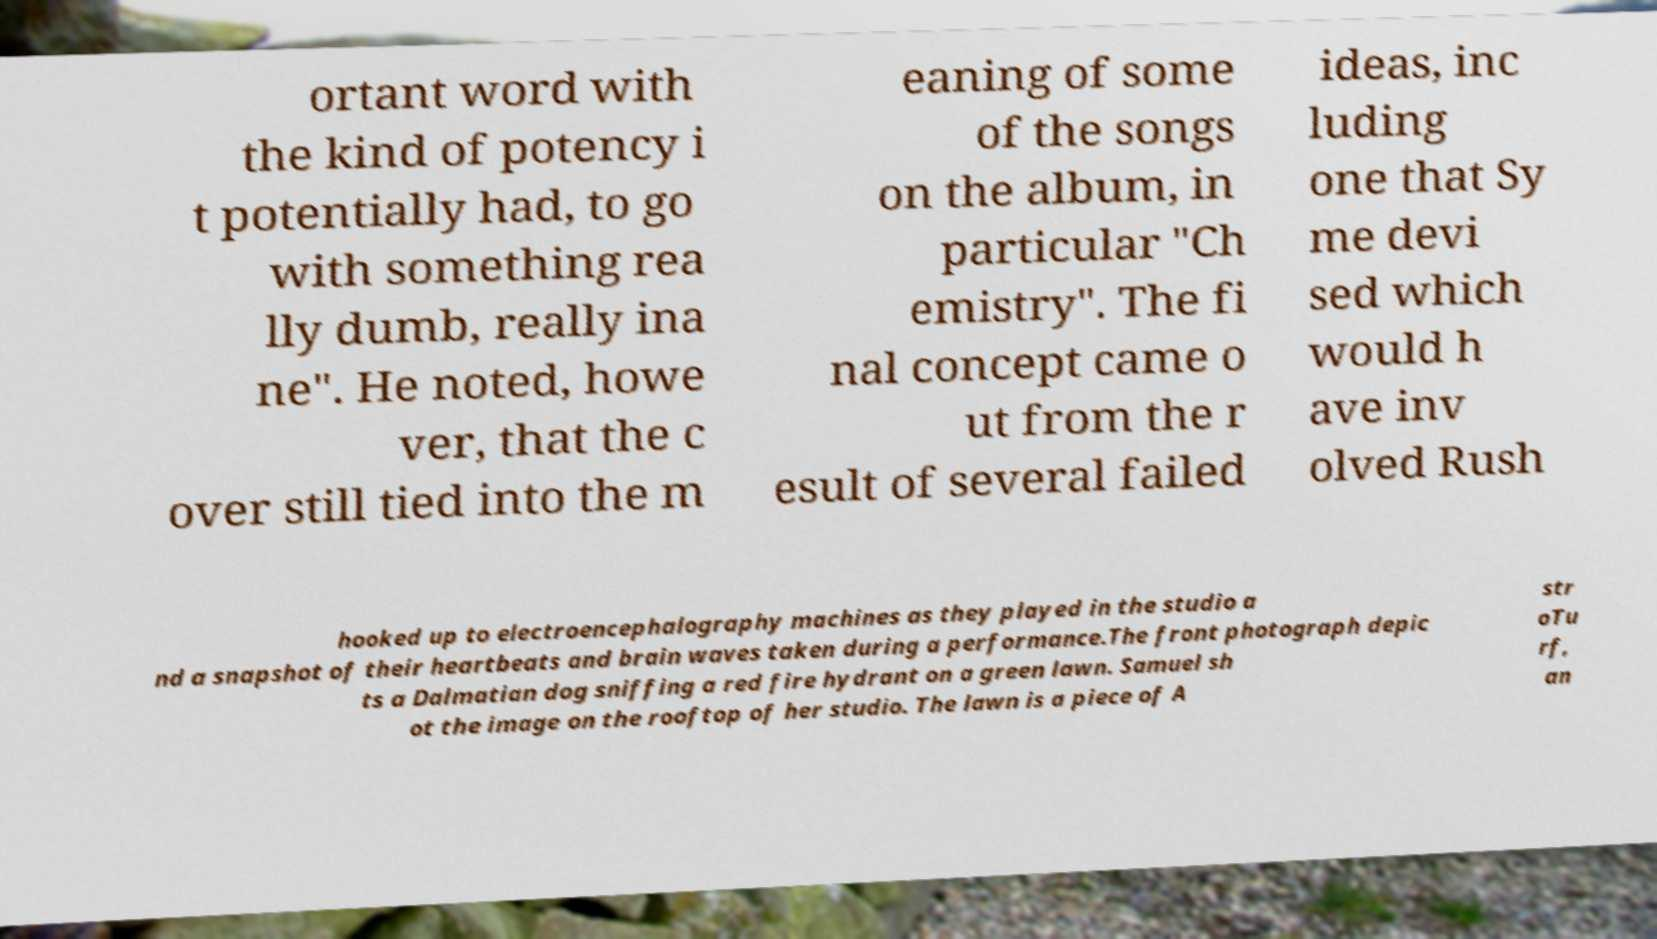Please read and relay the text visible in this image. What does it say? ortant word with the kind of potency i t potentially had, to go with something rea lly dumb, really ina ne". He noted, howe ver, that the c over still tied into the m eaning of some of the songs on the album, in particular "Ch emistry". The fi nal concept came o ut from the r esult of several failed ideas, inc luding one that Sy me devi sed which would h ave inv olved Rush hooked up to electroencephalography machines as they played in the studio a nd a snapshot of their heartbeats and brain waves taken during a performance.The front photograph depic ts a Dalmatian dog sniffing a red fire hydrant on a green lawn. Samuel sh ot the image on the rooftop of her studio. The lawn is a piece of A str oTu rf, an 